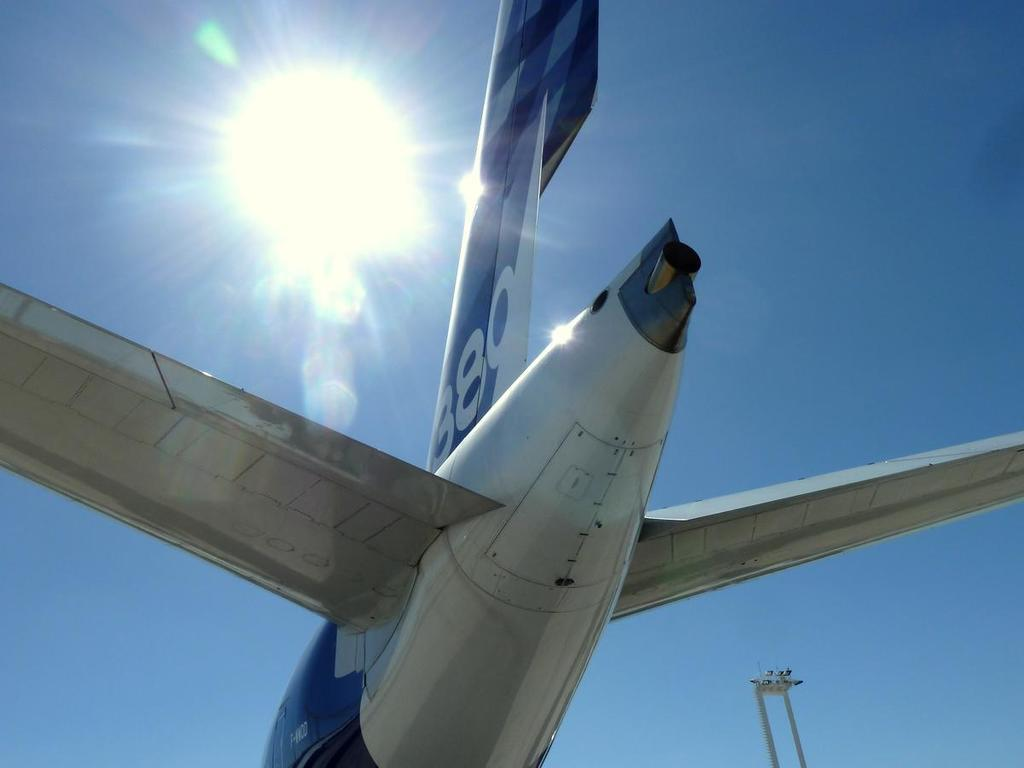<image>
Give a short and clear explanation of the subsequent image. A blue and silver plane has the number 389 on the tail. 